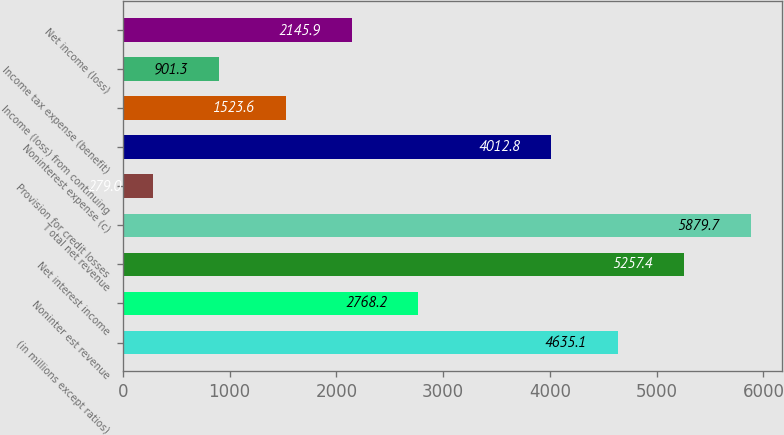Convert chart. <chart><loc_0><loc_0><loc_500><loc_500><bar_chart><fcel>(in millions except ratios)<fcel>Noninter est revenue<fcel>Net interest income<fcel>T otal net revenue<fcel>Provision for credit losses<fcel>Noninterest expense (c)<fcel>Income (loss) from continuing<fcel>Income tax expense (benefit)<fcel>Net income (loss)<nl><fcel>4635.1<fcel>2768.2<fcel>5257.4<fcel>5879.7<fcel>279<fcel>4012.8<fcel>1523.6<fcel>901.3<fcel>2145.9<nl></chart> 